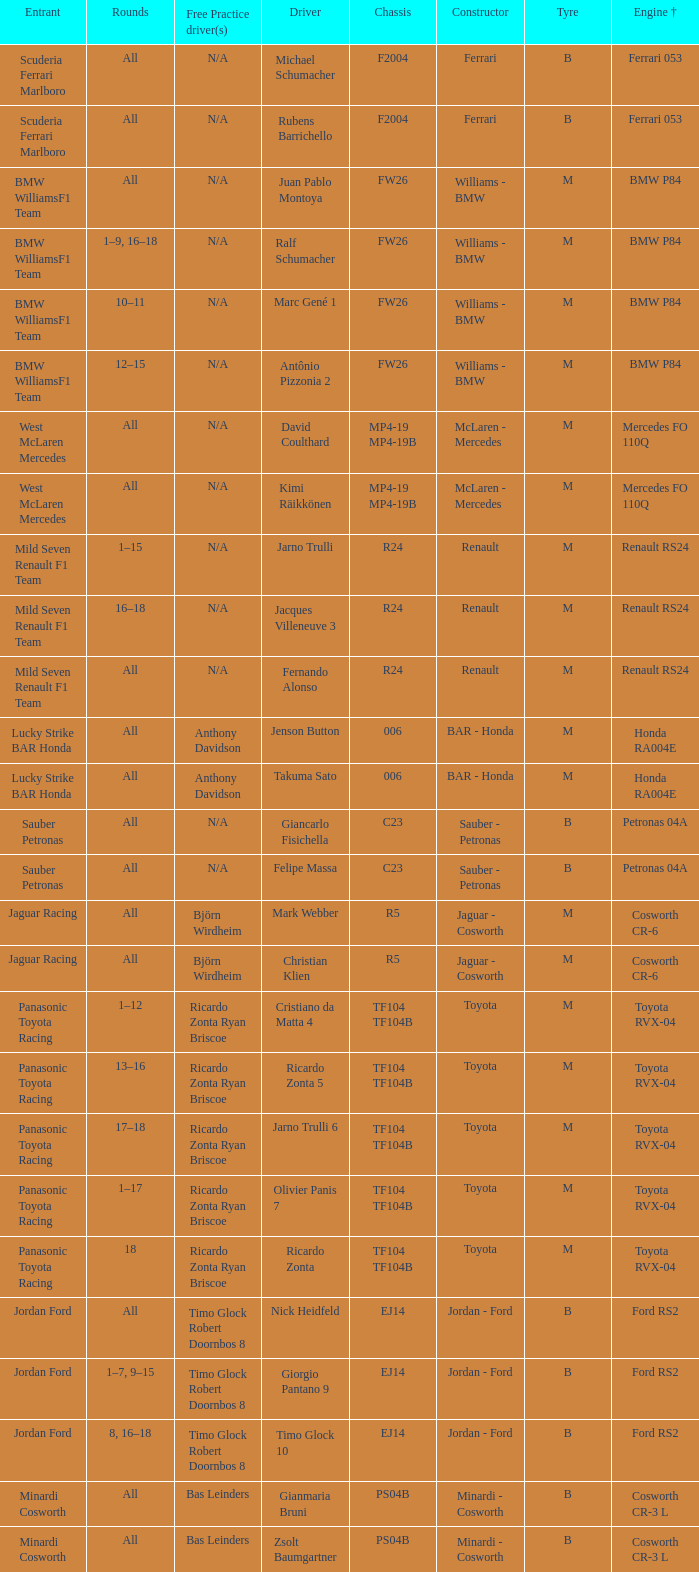What kind of chassis does Ricardo Zonta have? TF104 TF104B. 